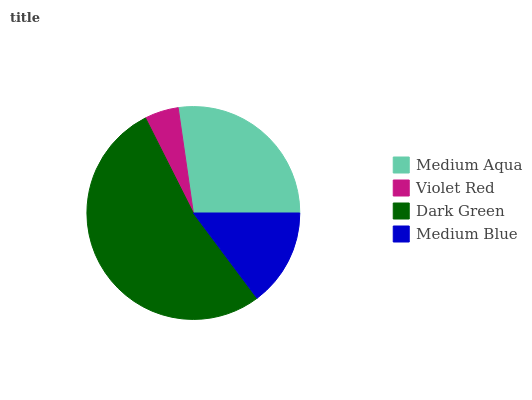Is Violet Red the minimum?
Answer yes or no. Yes. Is Dark Green the maximum?
Answer yes or no. Yes. Is Dark Green the minimum?
Answer yes or no. No. Is Violet Red the maximum?
Answer yes or no. No. Is Dark Green greater than Violet Red?
Answer yes or no. Yes. Is Violet Red less than Dark Green?
Answer yes or no. Yes. Is Violet Red greater than Dark Green?
Answer yes or no. No. Is Dark Green less than Violet Red?
Answer yes or no. No. Is Medium Aqua the high median?
Answer yes or no. Yes. Is Medium Blue the low median?
Answer yes or no. Yes. Is Violet Red the high median?
Answer yes or no. No. Is Violet Red the low median?
Answer yes or no. No. 